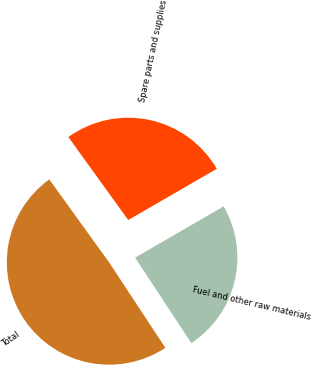Convert chart. <chart><loc_0><loc_0><loc_500><loc_500><pie_chart><fcel>Fuel and other raw materials<fcel>Spare parts and supplies<fcel>Total<nl><fcel>24.08%<fcel>26.6%<fcel>49.32%<nl></chart> 